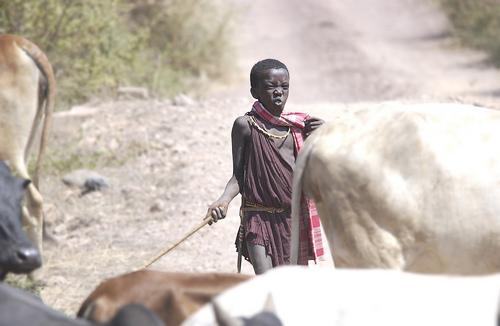Describe the types of animals and their characteristics present in the image. The image has white, beige, gray, black-faced, and tan and brown cows, some of them having tails, horns, and visible faces. What is the interaction between the child and the cows in the image? The child is herding the cows, possibly guiding them or guarding them, with a stick in hand. What is the object the child is holding, and how is it being held? The child is holding a brown stick, with fingers wrapped around it. Identify the primary activity being carried out by a child in this picture. A child is herding cows while carrying a stick and wearing a colorful scarf. List the main colors and objects you can find within the image. Some main colors seen are black, white, brown, green, red, pink, and purple; objects include children, cows, bushes, grass, a stick, a road, and rocks. What type of road is depicted in the image, and what lies on this road? A rocky dirt road is depicted, with rocks and tall green grass on it. What is the landscape like where the image is taking place? The landscape contains rocky dirt roads, tall green grass, and green bushes, with a rural atmosphere where cows and humans interact. Describe the appearance of the boy holding the stick. The boy has black hair, is wearing a colorful scarf, and is holding a stick, while making a face and having a scrunched-up expression. How many cows can be seen in the image, and what are the main colors of these cows? There are at least five cows visible, with colors including white, beige, gray, black-faced, and tan and brown. Among the cows present in the image, is there any that appears to be looking at the camera? Yes, there is a black cow looking at the camera. 